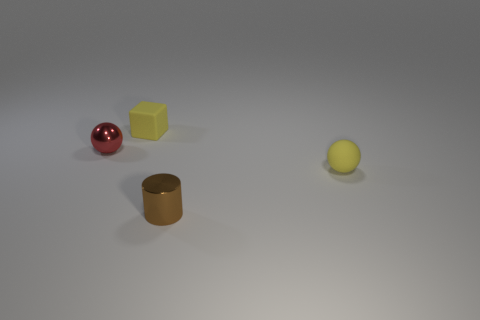There is a thing that is on the left side of the matte cube; is its shape the same as the small yellow matte thing to the right of the tiny cylinder?
Offer a terse response. Yes. There is a matte object that is the same color as the small matte cube; what is its size?
Provide a short and direct response. Small. There is a rubber cube; does it have the same color as the small sphere in front of the red shiny sphere?
Your answer should be compact. Yes. Is the number of tiny metal cylinders to the left of the yellow sphere less than the number of brown things that are in front of the brown metal cylinder?
Your answer should be very brief. No. The object that is on the left side of the tiny yellow sphere and on the right side of the small yellow block is what color?
Ensure brevity in your answer.  Brown. Does the red thing have the same size as the yellow rubber object that is in front of the small red ball?
Offer a terse response. Yes. There is a small object on the right side of the brown metallic cylinder; what shape is it?
Offer a terse response. Sphere. Is there anything else that has the same material as the tiny red ball?
Your answer should be very brief. Yes. Is the number of shiny things behind the brown cylinder greater than the number of small shiny cubes?
Provide a short and direct response. Yes. How many yellow things are behind the sphere that is left of the tiny cylinder right of the yellow rubber cube?
Make the answer very short. 1. 